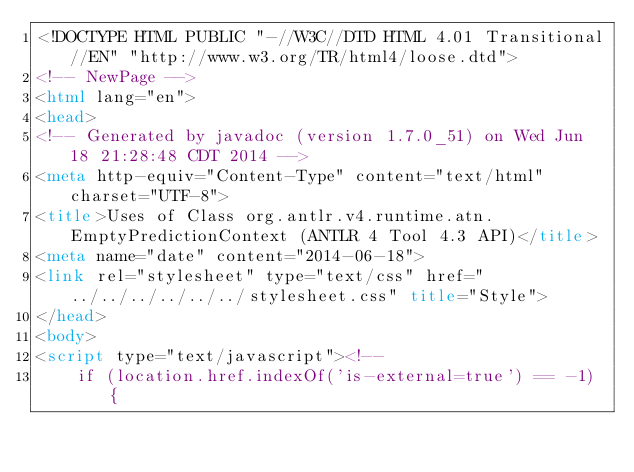<code> <loc_0><loc_0><loc_500><loc_500><_HTML_><!DOCTYPE HTML PUBLIC "-//W3C//DTD HTML 4.01 Transitional//EN" "http://www.w3.org/TR/html4/loose.dtd">
<!-- NewPage -->
<html lang="en">
<head>
<!-- Generated by javadoc (version 1.7.0_51) on Wed Jun 18 21:28:48 CDT 2014 -->
<meta http-equiv="Content-Type" content="text/html" charset="UTF-8">
<title>Uses of Class org.antlr.v4.runtime.atn.EmptyPredictionContext (ANTLR 4 Tool 4.3 API)</title>
<meta name="date" content="2014-06-18">
<link rel="stylesheet" type="text/css" href="../../../../../../stylesheet.css" title="Style">
</head>
<body>
<script type="text/javascript"><!--
    if (location.href.indexOf('is-external=true') == -1) {</code> 